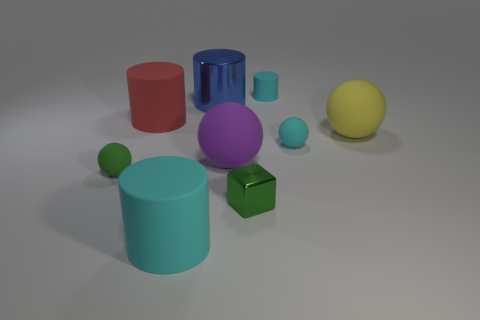Are there more cyan objects that are right of the small cyan matte cylinder than brown shiny cylinders?
Make the answer very short. Yes. Is the shape of the yellow object the same as the blue thing?
Make the answer very short. No. How many red objects have the same material as the tiny cylinder?
Your answer should be compact. 1. What is the size of the green matte thing that is the same shape as the purple object?
Your response must be concise. Small. Is the yellow rubber ball the same size as the cyan sphere?
Give a very brief answer. No. There is a thing that is left of the large matte cylinder that is behind the cyan cylinder that is in front of the yellow matte ball; what is its shape?
Your answer should be very brief. Sphere. There is another small thing that is the same shape as the green matte thing; what is its color?
Give a very brief answer. Cyan. What size is the rubber object that is both to the left of the small cyan sphere and to the right of the small green block?
Make the answer very short. Small. There is a matte thing on the left side of the big rubber cylinder behind the green metal cube; what number of purple spheres are behind it?
Your answer should be very brief. 1. How many tiny objects are either balls or red rubber cylinders?
Provide a short and direct response. 2. 